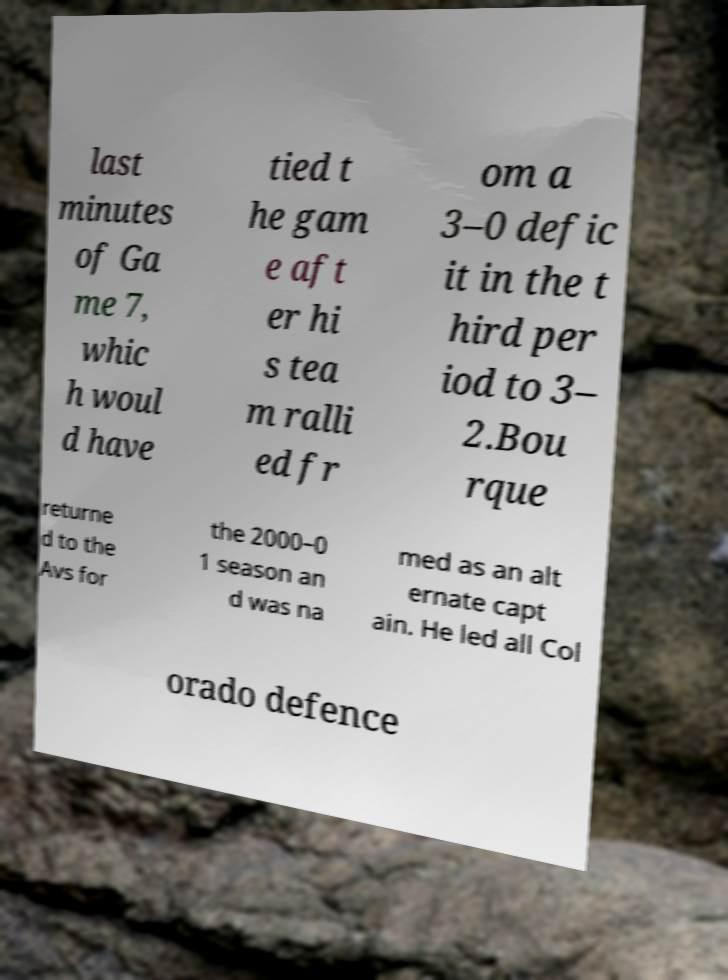I need the written content from this picture converted into text. Can you do that? last minutes of Ga me 7, whic h woul d have tied t he gam e aft er hi s tea m ralli ed fr om a 3–0 defic it in the t hird per iod to 3– 2.Bou rque returne d to the Avs for the 2000–0 1 season an d was na med as an alt ernate capt ain. He led all Col orado defence 